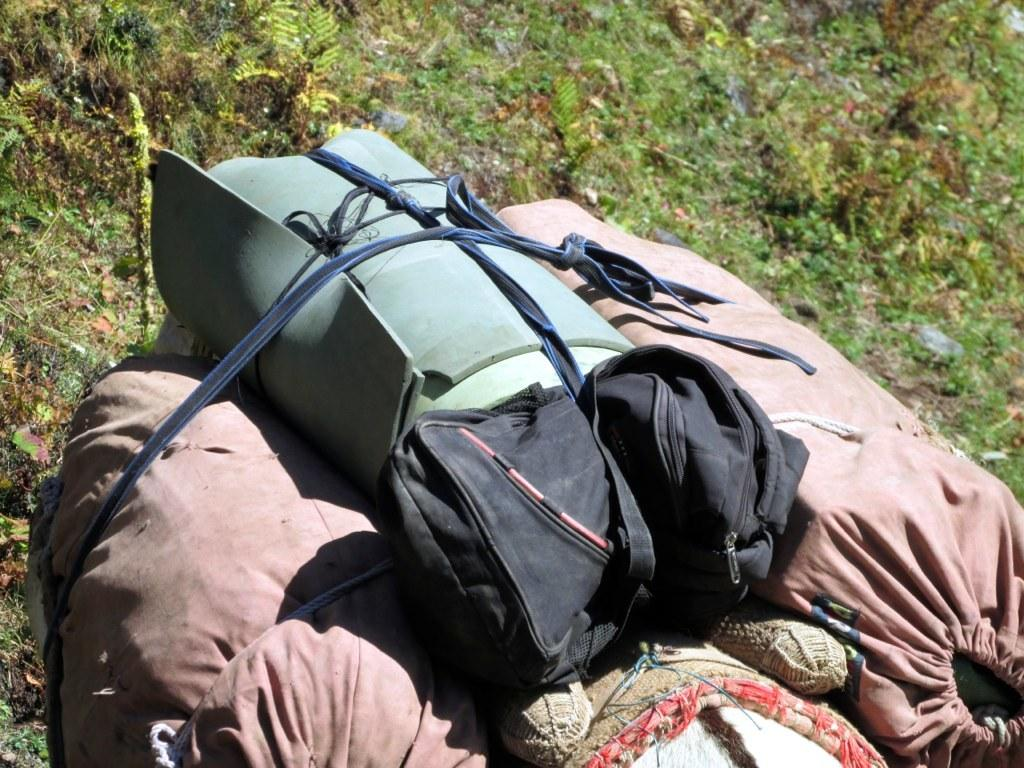What objects can be seen in the image? There are bags in the image. What type of vegetation is present in the image? There is grass in the image. What type of sock is hanging on the corn in the image? There is no sock or corn present in the image. How many crates are visible in the image? There are no crates visible in the image. 